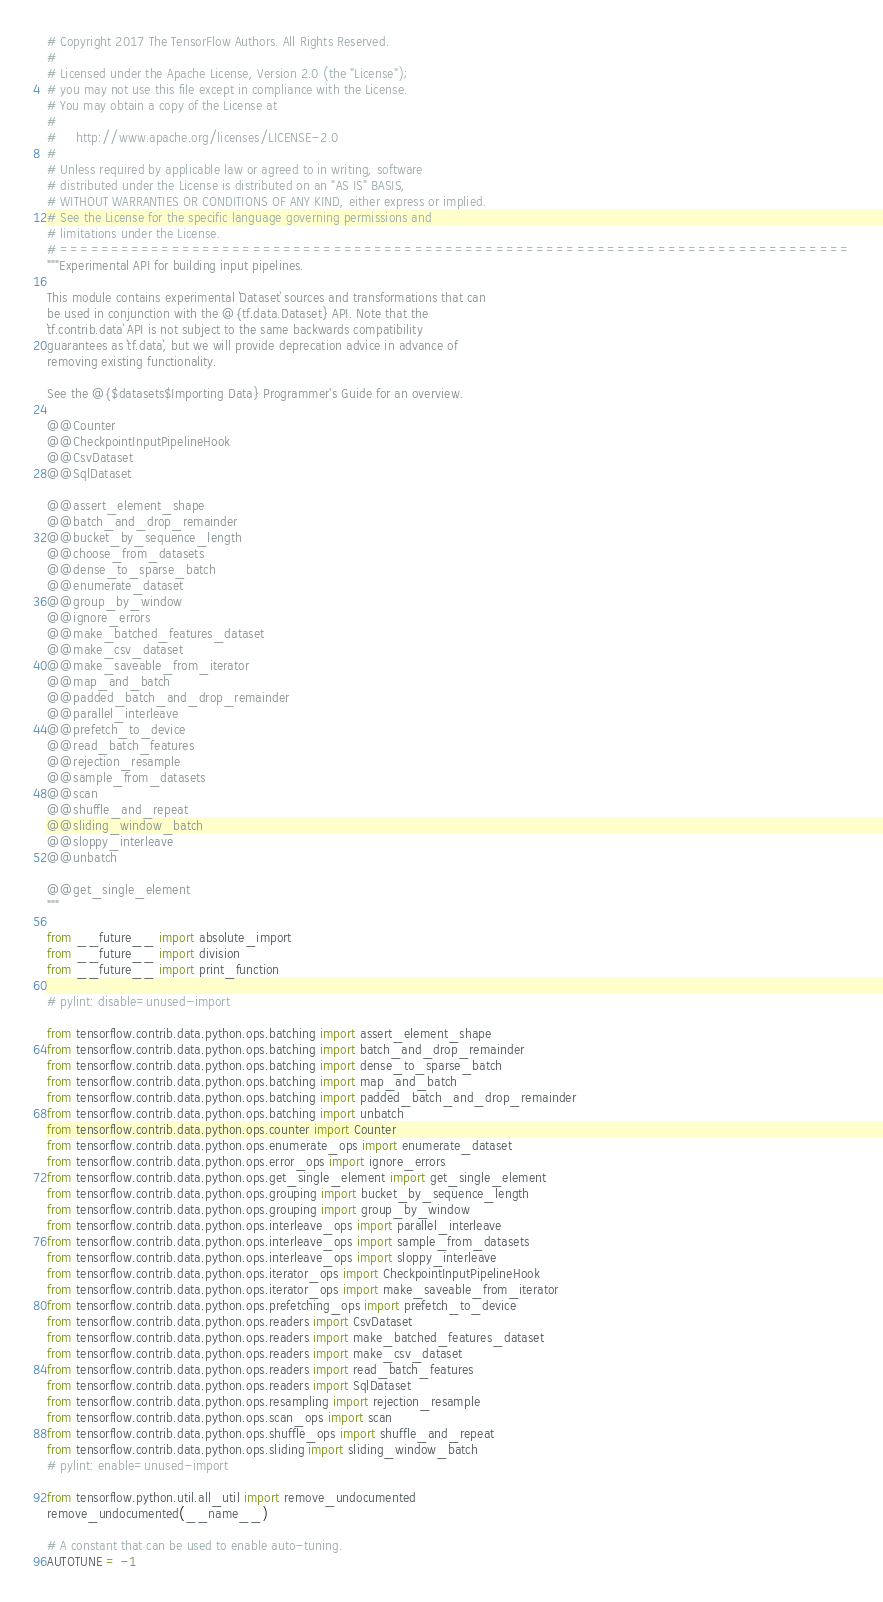<code> <loc_0><loc_0><loc_500><loc_500><_Python_># Copyright 2017 The TensorFlow Authors. All Rights Reserved.
#
# Licensed under the Apache License, Version 2.0 (the "License");
# you may not use this file except in compliance with the License.
# You may obtain a copy of the License at
#
#     http://www.apache.org/licenses/LICENSE-2.0
#
# Unless required by applicable law or agreed to in writing, software
# distributed under the License is distributed on an "AS IS" BASIS,
# WITHOUT WARRANTIES OR CONDITIONS OF ANY KIND, either express or implied.
# See the License for the specific language governing permissions and
# limitations under the License.
# ==============================================================================
"""Experimental API for building input pipelines.

This module contains experimental `Dataset` sources and transformations that can
be used in conjunction with the @{tf.data.Dataset} API. Note that the
`tf.contrib.data` API is not subject to the same backwards compatibility
guarantees as `tf.data`, but we will provide deprecation advice in advance of
removing existing functionality.

See the @{$datasets$Importing Data} Programmer's Guide for an overview.

@@Counter
@@CheckpointInputPipelineHook
@@CsvDataset
@@SqlDataset

@@assert_element_shape
@@batch_and_drop_remainder
@@bucket_by_sequence_length
@@choose_from_datasets
@@dense_to_sparse_batch
@@enumerate_dataset
@@group_by_window
@@ignore_errors
@@make_batched_features_dataset
@@make_csv_dataset
@@make_saveable_from_iterator
@@map_and_batch
@@padded_batch_and_drop_remainder
@@parallel_interleave
@@prefetch_to_device
@@read_batch_features
@@rejection_resample
@@sample_from_datasets
@@scan
@@shuffle_and_repeat
@@sliding_window_batch
@@sloppy_interleave
@@unbatch

@@get_single_element
"""

from __future__ import absolute_import
from __future__ import division
from __future__ import print_function

# pylint: disable=unused-import

from tensorflow.contrib.data.python.ops.batching import assert_element_shape
from tensorflow.contrib.data.python.ops.batching import batch_and_drop_remainder
from tensorflow.contrib.data.python.ops.batching import dense_to_sparse_batch
from tensorflow.contrib.data.python.ops.batching import map_and_batch
from tensorflow.contrib.data.python.ops.batching import padded_batch_and_drop_remainder
from tensorflow.contrib.data.python.ops.batching import unbatch
from tensorflow.contrib.data.python.ops.counter import Counter
from tensorflow.contrib.data.python.ops.enumerate_ops import enumerate_dataset
from tensorflow.contrib.data.python.ops.error_ops import ignore_errors
from tensorflow.contrib.data.python.ops.get_single_element import get_single_element
from tensorflow.contrib.data.python.ops.grouping import bucket_by_sequence_length
from tensorflow.contrib.data.python.ops.grouping import group_by_window
from tensorflow.contrib.data.python.ops.interleave_ops import parallel_interleave
from tensorflow.contrib.data.python.ops.interleave_ops import sample_from_datasets
from tensorflow.contrib.data.python.ops.interleave_ops import sloppy_interleave
from tensorflow.contrib.data.python.ops.iterator_ops import CheckpointInputPipelineHook
from tensorflow.contrib.data.python.ops.iterator_ops import make_saveable_from_iterator
from tensorflow.contrib.data.python.ops.prefetching_ops import prefetch_to_device
from tensorflow.contrib.data.python.ops.readers import CsvDataset
from tensorflow.contrib.data.python.ops.readers import make_batched_features_dataset
from tensorflow.contrib.data.python.ops.readers import make_csv_dataset
from tensorflow.contrib.data.python.ops.readers import read_batch_features
from tensorflow.contrib.data.python.ops.readers import SqlDataset
from tensorflow.contrib.data.python.ops.resampling import rejection_resample
from tensorflow.contrib.data.python.ops.scan_ops import scan
from tensorflow.contrib.data.python.ops.shuffle_ops import shuffle_and_repeat
from tensorflow.contrib.data.python.ops.sliding import sliding_window_batch
# pylint: enable=unused-import

from tensorflow.python.util.all_util import remove_undocumented
remove_undocumented(__name__)

# A constant that can be used to enable auto-tuning.
AUTOTUNE = -1
</code> 